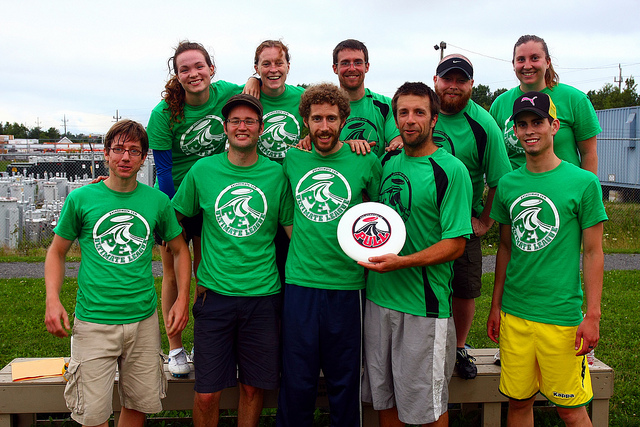Identify the text displayed in this image. PEI PEI PEI LEARNT P 